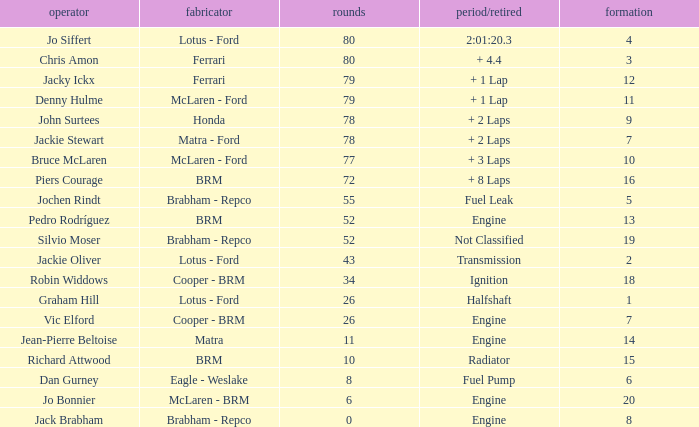When laps are less than 80 and Bruce mclaren is the driver, what is the grid? 10.0. 